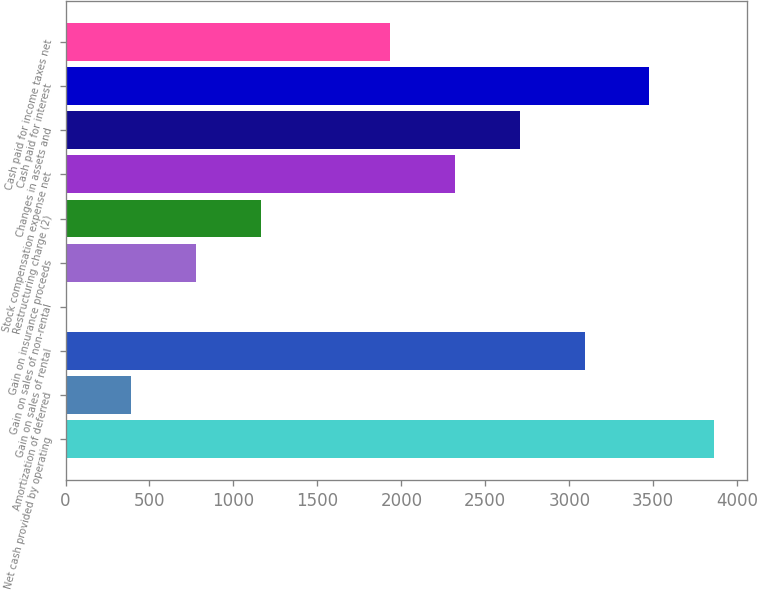Convert chart. <chart><loc_0><loc_0><loc_500><loc_500><bar_chart><fcel>Net cash provided by operating<fcel>Amortization of deferred<fcel>Gain on sales of rental<fcel>Gain on sales of non-rental<fcel>Gain on insurance proceeds<fcel>Restructuring charge (2)<fcel>Stock compensation expense net<fcel>Changes in assets and<fcel>Cash paid for interest<fcel>Cash paid for income taxes net<nl><fcel>3863<fcel>391.7<fcel>3091.6<fcel>6<fcel>777.4<fcel>1163.1<fcel>2320.2<fcel>2705.9<fcel>3477.3<fcel>1934.5<nl></chart> 